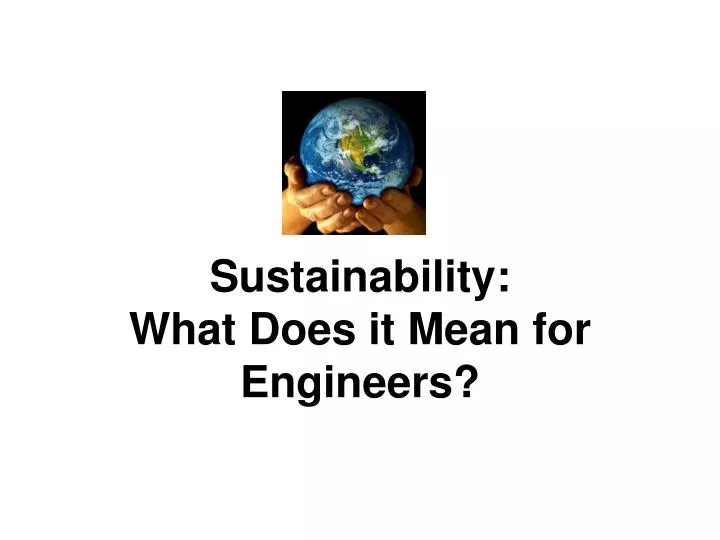How do the elements in the image illustrate the concept of global responsibility in engineering? The image uses the symbol of hands gently holding the Earth to convey a message of global responsibility. This implies that engineers hold the power and duty to protect and sustain the planet. The image suggests that every engineering decision has a ripple effect on the environment, highlighting the importance of sustainable practices. By prioritizing eco-friendly materials, renewable energy, and efficient design, engineers can contribute to the well-being of the entire planet. Can you provide examples of sustainable engineering practices that align with the theme of the image? Certainly! Here are a few examples:
1. **Green Building Design**: Using sustainable materials, optimizing energy efficiency, and incorporating renewable energy sources like solar panels and wind turbines.
2. **Water Conservation Technologies**: Designing systems that recycle water, use greywater for irrigation, and reduce water wastage.
3. **Sustainable Transportation**: Developing electric vehicles, efficient public transport systems, and infrastructure that supports cycling and walking.
4. **Waste Management Solutions**: Creating methods to reduce, recycle, and repurpose waste materials.
5. **Renewable Energy Projects**: Implementing solar, wind, and hydroelectric power solutions to reduce reliance on fossil fuels. 